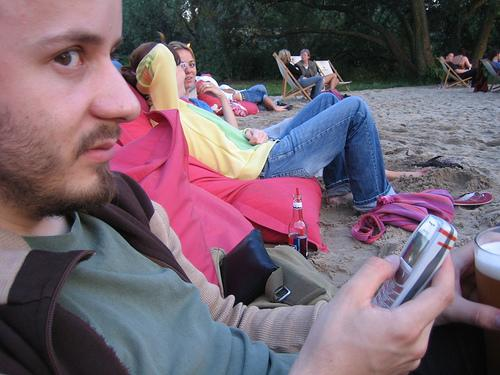What kind of ground are these people sitting on?

Choices:
A) ash
B) sand
C) marble
D) concrete sand 